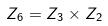<formula> <loc_0><loc_0><loc_500><loc_500>Z _ { 6 } = Z _ { 3 } \times Z _ { 2 }</formula> 